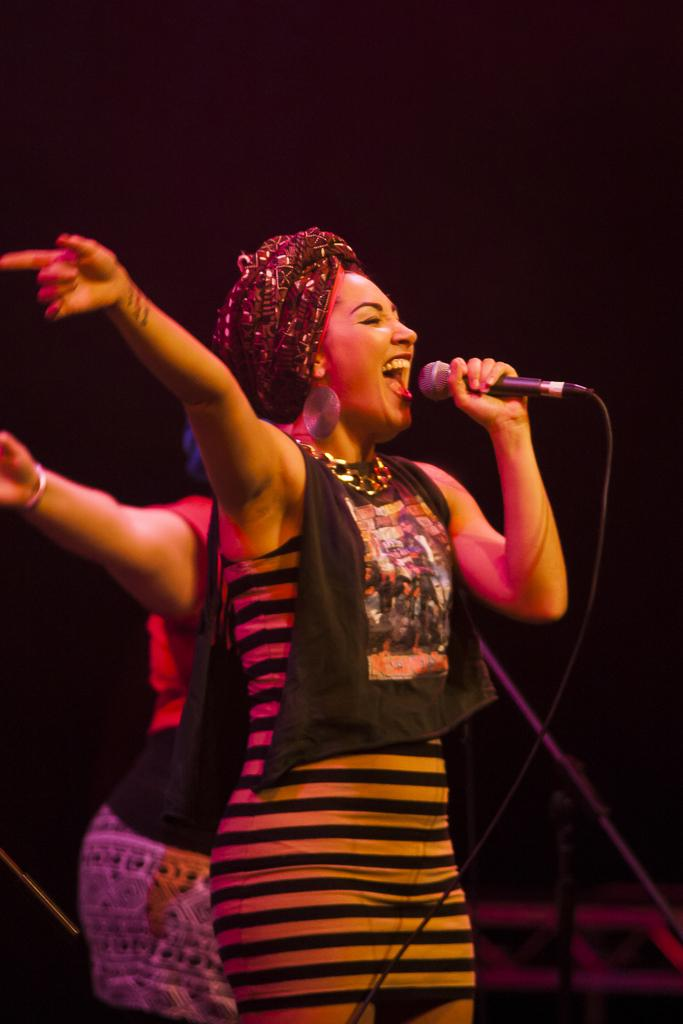What is the main subject of the image? The main subject of the image is a woman standing in the middle. What is the woman holding in the image? The woman is holding a black microphone. What is the woman doing with the microphone? The woman is singing while holding the microphone. Can you describe the other person in the image? There is another woman standing in the background of the image. What type of connection does the woman have with her father in the image? There is no mention of a father or any connection in the image. The image only shows a woman singing with a microphone and another woman in the background. 